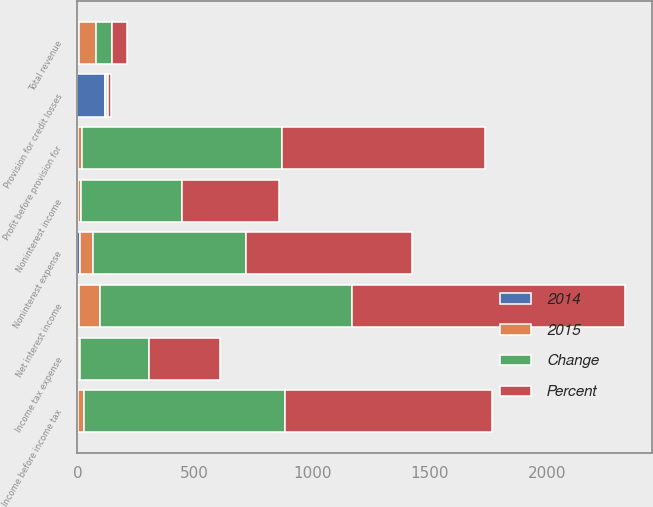<chart> <loc_0><loc_0><loc_500><loc_500><stacked_bar_chart><ecel><fcel>Net interest income<fcel>Noninterest income<fcel>Total revenue<fcel>Noninterest expense<fcel>Profit before provision for<fcel>Provision for credit losses<fcel>Income before income tax<fcel>Income tax expense<nl><fcel>Percent<fcel>1162<fcel>415<fcel>66<fcel>709<fcel>868<fcel>13<fcel>881<fcel>302<nl><fcel>Change<fcel>1073<fcel>429<fcel>66<fcel>652<fcel>850<fcel>6<fcel>856<fcel>295<nl><fcel>2015<fcel>89<fcel>14<fcel>75<fcel>57<fcel>18<fcel>7<fcel>25<fcel>7<nl><fcel>2014<fcel>8<fcel>3<fcel>5<fcel>9<fcel>2<fcel>117<fcel>3<fcel>2<nl></chart> 